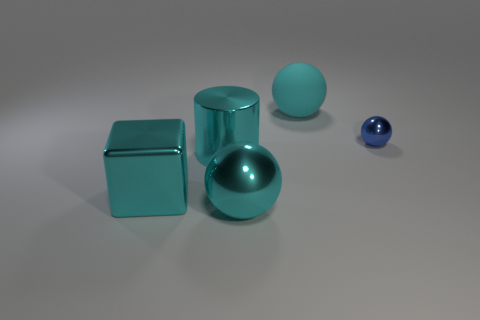Is there any other thing that is the same size as the blue thing?
Offer a terse response. No. What number of large cyan spheres are there?
Offer a very short reply. 2. Is the size of the thing on the right side of the big cyan rubber object the same as the cyan shiny cylinder that is in front of the blue sphere?
Your answer should be very brief. No. There is another large thing that is the same shape as the rubber thing; what color is it?
Ensure brevity in your answer.  Cyan. There is another cyan object that is the same shape as the cyan matte thing; what is its size?
Give a very brief answer. Large. How many cyan cylinders have the same material as the block?
Provide a succinct answer. 1. What number of things are green metal cubes or large cyan cylinders?
Ensure brevity in your answer.  1. There is a big thing that is behind the big cyan cylinder; is there a cyan rubber object that is behind it?
Give a very brief answer. No. Are there more large spheres that are in front of the cyan rubber sphere than big cyan cubes that are in front of the big cube?
Offer a very short reply. Yes. There is a cube that is the same color as the large cylinder; what is it made of?
Your answer should be very brief. Metal. 